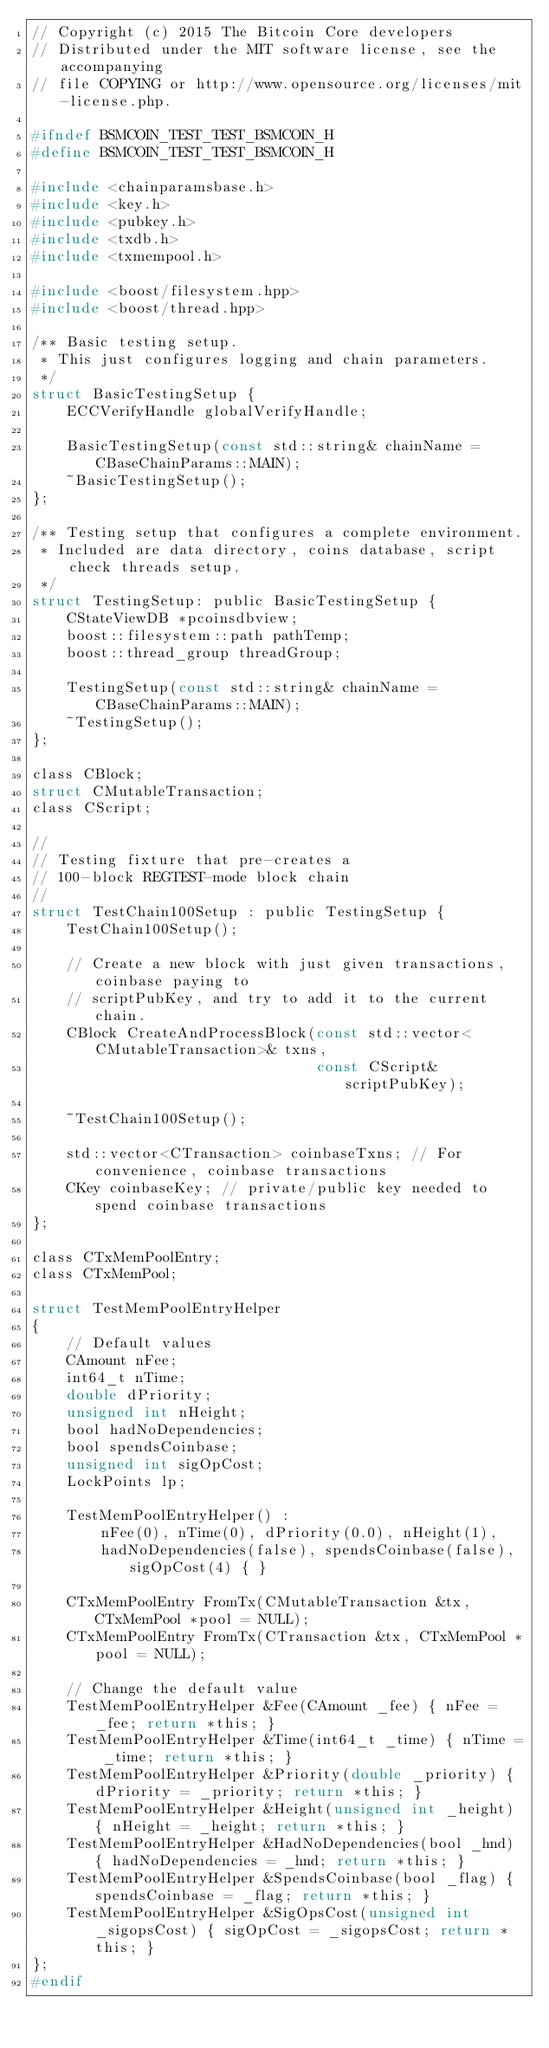Convert code to text. <code><loc_0><loc_0><loc_500><loc_500><_C_>// Copyright (c) 2015 The Bitcoin Core developers
// Distributed under the MIT software license, see the accompanying
// file COPYING or http://www.opensource.org/licenses/mit-license.php.

#ifndef BSMCOIN_TEST_TEST_BSMCOIN_H
#define BSMCOIN_TEST_TEST_BSMCOIN_H

#include <chainparamsbase.h>
#include <key.h>
#include <pubkey.h>
#include <txdb.h>
#include <txmempool.h>

#include <boost/filesystem.hpp>
#include <boost/thread.hpp>

/** Basic testing setup.
 * This just configures logging and chain parameters.
 */
struct BasicTestingSetup {
    ECCVerifyHandle globalVerifyHandle;

    BasicTestingSetup(const std::string& chainName = CBaseChainParams::MAIN);
    ~BasicTestingSetup();
};

/** Testing setup that configures a complete environment.
 * Included are data directory, coins database, script check threads setup.
 */
struct TestingSetup: public BasicTestingSetup {
    CStateViewDB *pcoinsdbview;
    boost::filesystem::path pathTemp;
    boost::thread_group threadGroup;

    TestingSetup(const std::string& chainName = CBaseChainParams::MAIN);
    ~TestingSetup();
};

class CBlock;
struct CMutableTransaction;
class CScript;

//
// Testing fixture that pre-creates a
// 100-block REGTEST-mode block chain
//
struct TestChain100Setup : public TestingSetup {
    TestChain100Setup();

    // Create a new block with just given transactions, coinbase paying to
    // scriptPubKey, and try to add it to the current chain.
    CBlock CreateAndProcessBlock(const std::vector<CMutableTransaction>& txns,
                                 const CScript& scriptPubKey);

    ~TestChain100Setup();

    std::vector<CTransaction> coinbaseTxns; // For convenience, coinbase transactions
    CKey coinbaseKey; // private/public key needed to spend coinbase transactions
};

class CTxMemPoolEntry;
class CTxMemPool;

struct TestMemPoolEntryHelper
{
    // Default values
    CAmount nFee;
    int64_t nTime;
    double dPriority;
    unsigned int nHeight;
    bool hadNoDependencies;
    bool spendsCoinbase;
    unsigned int sigOpCost;
    LockPoints lp;

    TestMemPoolEntryHelper() :
        nFee(0), nTime(0), dPriority(0.0), nHeight(1),
        hadNoDependencies(false), spendsCoinbase(false), sigOpCost(4) { }
    
    CTxMemPoolEntry FromTx(CMutableTransaction &tx, CTxMemPool *pool = NULL);
    CTxMemPoolEntry FromTx(CTransaction &tx, CTxMemPool *pool = NULL);

    // Change the default value
    TestMemPoolEntryHelper &Fee(CAmount _fee) { nFee = _fee; return *this; }
    TestMemPoolEntryHelper &Time(int64_t _time) { nTime = _time; return *this; }
    TestMemPoolEntryHelper &Priority(double _priority) { dPriority = _priority; return *this; }
    TestMemPoolEntryHelper &Height(unsigned int _height) { nHeight = _height; return *this; }
    TestMemPoolEntryHelper &HadNoDependencies(bool _hnd) { hadNoDependencies = _hnd; return *this; }
    TestMemPoolEntryHelper &SpendsCoinbase(bool _flag) { spendsCoinbase = _flag; return *this; }
    TestMemPoolEntryHelper &SigOpsCost(unsigned int _sigopsCost) { sigOpCost = _sigopsCost; return *this; }
};
#endif
</code> 